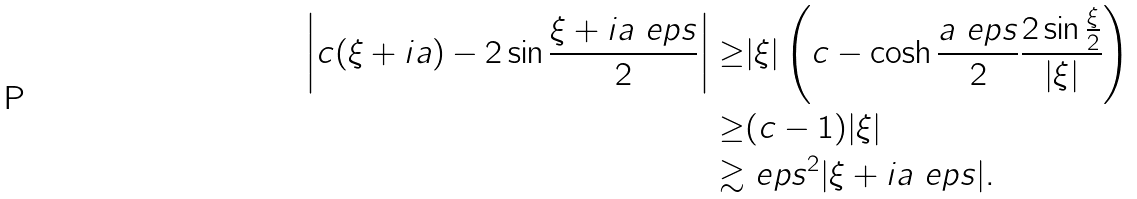<formula> <loc_0><loc_0><loc_500><loc_500>\left | c ( \xi + i a ) - 2 \sin \frac { \xi + i a \ e p s } { 2 } \right | \geq & | \xi | \left ( c - \cosh \frac { a \ e p s } { 2 } \frac { 2 \sin \frac { \xi } { 2 } } { | \xi | } \right ) \\ \geq & ( c - 1 ) | \xi | \\ \gtrsim & \ e p s ^ { 2 } | \xi + i a \ e p s | .</formula> 